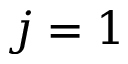Convert formula to latex. <formula><loc_0><loc_0><loc_500><loc_500>j = 1</formula> 